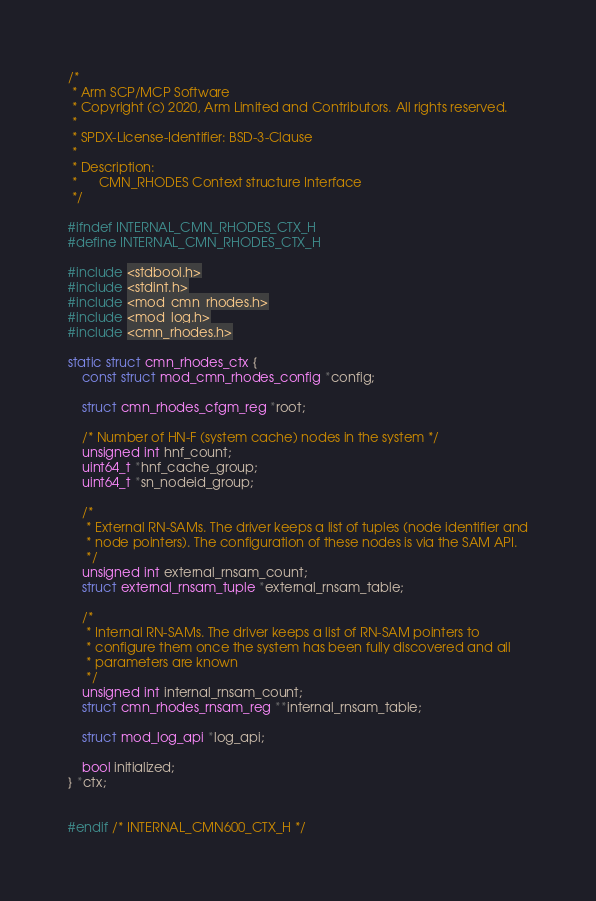Convert code to text. <code><loc_0><loc_0><loc_500><loc_500><_C_>/*
 * Arm SCP/MCP Software
 * Copyright (c) 2020, Arm Limited and Contributors. All rights reserved.
 *
 * SPDX-License-Identifier: BSD-3-Clause
 *
 * Description:
 *      CMN_RHODES Context structure Interface
 */

#ifndef INTERNAL_CMN_RHODES_CTX_H
#define INTERNAL_CMN_RHODES_CTX_H

#include <stdbool.h>
#include <stdint.h>
#include <mod_cmn_rhodes.h>
#include <mod_log.h>
#include <cmn_rhodes.h>

static struct cmn_rhodes_ctx {
    const struct mod_cmn_rhodes_config *config;

    struct cmn_rhodes_cfgm_reg *root;

    /* Number of HN-F (system cache) nodes in the system */
    unsigned int hnf_count;
    uint64_t *hnf_cache_group;
    uint64_t *sn_nodeid_group;

    /*
     * External RN-SAMs. The driver keeps a list of tuples (node identifier and
     * node pointers). The configuration of these nodes is via the SAM API.
     */
    unsigned int external_rnsam_count;
    struct external_rnsam_tuple *external_rnsam_table;

    /*
     * Internal RN-SAMs. The driver keeps a list of RN-SAM pointers to
     * configure them once the system has been fully discovered and all
     * parameters are known
     */
    unsigned int internal_rnsam_count;
    struct cmn_rhodes_rnsam_reg **internal_rnsam_table;

    struct mod_log_api *log_api;

    bool initialized;
} *ctx;


#endif /* INTERNAL_CMN600_CTX_H */
</code> 